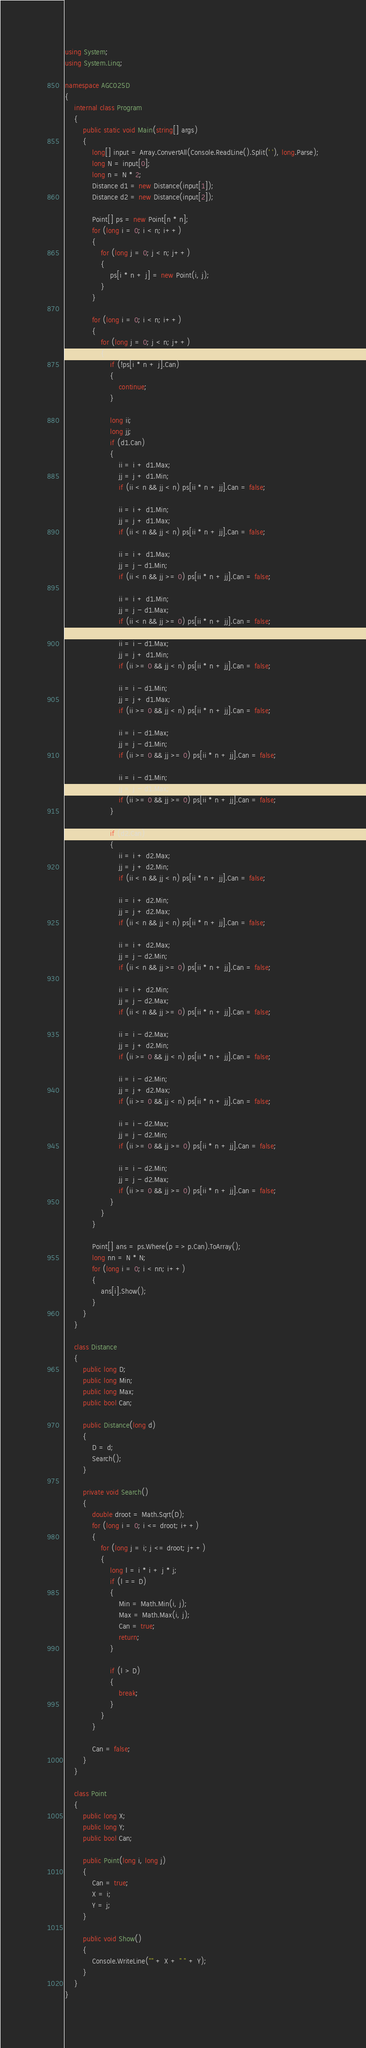<code> <loc_0><loc_0><loc_500><loc_500><_C#_>using System;
using System.Linq;

namespace AGC025D
{
    internal class Program
    {
        public static void Main(string[] args)
        {
            long[] input = Array.ConvertAll(Console.ReadLine().Split(' '), long.Parse);
            long N = input[0];
            long n = N * 2;
            Distance d1 = new Distance(input[1]);
            Distance d2 = new Distance(input[2]);

            Point[] ps = new Point[n * n];
            for (long i = 0; i < n; i++)
            {
                for (long j = 0; j < n; j++)
                {
                    ps[i * n + j] = new Point(i, j);
                }
            }

            for (long i = 0; i < n; i++)
            {
                for (long j = 0; j < n; j++)
                {
                    if (!ps[i * n + j].Can)
                    {
                        continue;
                    }

                    long ii;
                    long jj;
                    if (d1.Can)
                    {
                        ii = i + d1.Max;
                        jj = j + d1.Min;
                        if (ii < n && jj < n) ps[ii * n + jj].Can = false;

                        ii = i + d1.Min;
                        jj = j + d1.Max;
                        if (ii < n && jj < n) ps[ii * n + jj].Can = false;
                        
                        ii = i + d1.Max;
                        jj = j - d1.Min;
                        if (ii < n && jj >= 0) ps[ii * n + jj].Can = false;

                        ii = i + d1.Min;
                        jj = j - d1.Max;
                        if (ii < n && jj >= 0) ps[ii * n + jj].Can = false;
                                                
                        ii = i - d1.Max;
                        jj = j + d1.Min;
                        if (ii >= 0 && jj < n) ps[ii * n + jj].Can = false;

                        ii = i - d1.Min;
                        jj = j + d1.Max;
                        if (ii >= 0 && jj < n) ps[ii * n + jj].Can = false;
                        
                        ii = i - d1.Max;
                        jj = j - d1.Min;
                        if (ii >= 0 && jj >= 0) ps[ii * n + jj].Can = false;

                        ii = i - d1.Min;
                        jj = j - d1.Max;
                        if (ii >= 0 && jj >= 0) ps[ii * n + jj].Can = false;
                    }

                    if (d2.Can)
                    {
                        ii = i + d2.Max;
                        jj = j + d2.Min;
                        if (ii < n && jj < n) ps[ii * n + jj].Can = false;

                        ii = i + d2.Min;
                        jj = j + d2.Max;
                        if (ii < n && jj < n) ps[ii * n + jj].Can = false;
                        
                        ii = i + d2.Max;
                        jj = j - d2.Min;
                        if (ii < n && jj >= 0) ps[ii * n + jj].Can = false;

                        ii = i + d2.Min;
                        jj = j - d2.Max;
                        if (ii < n && jj >= 0) ps[ii * n + jj].Can = false;
                        
                        ii = i - d2.Max;
                        jj = j + d2.Min;
                        if (ii >= 0 && jj < n) ps[ii * n + jj].Can = false;

                        ii = i - d2.Min;
                        jj = j + d2.Max;
                        if (ii >= 0 && jj < n) ps[ii * n + jj].Can = false;
                        
                        ii = i - d2.Max;
                        jj = j - d2.Min;
                        if (ii >= 0 && jj >= 0) ps[ii * n + jj].Can = false;

                        ii = i - d2.Min;
                        jj = j - d2.Max;
                        if (ii >= 0 && jj >= 0) ps[ii * n + jj].Can = false;
                    }
                }
            }

            Point[] ans = ps.Where(p => p.Can).ToArray();
            long nn = N * N;
            for (long i = 0; i < nn; i++)
            {
                ans[i].Show();
            }
        }
    }

    class Distance
    {
        public long D;
        public long Min;
        public long Max;
        public bool Can;

        public Distance(long d)
        {
            D = d;
            Search();
        }

        private void Search()
        {
            double droot = Math.Sqrt(D);
            for (long i = 0; i <= droot; i++)
            {
                for (long j = i; j <= droot; j++)
                {
                    long l = i * i + j * j;
                    if (l == D)
                    {
                        Min = Math.Min(i, j);
                        Max = Math.Max(i, j);
                        Can = true;
                        return;
                    }

                    if (l > D)
                    {
                        break;
                    }
                }
            }

            Can = false;
        }
    }

    class Point
    {
        public long X;
        public long Y;
        public bool Can;

        public Point(long i, long j)
        {
            Can = true;
            X = i;
            Y = j;
        }

        public void Show()
        {
            Console.WriteLine("" + X + " " + Y);
        }
    }
}</code> 